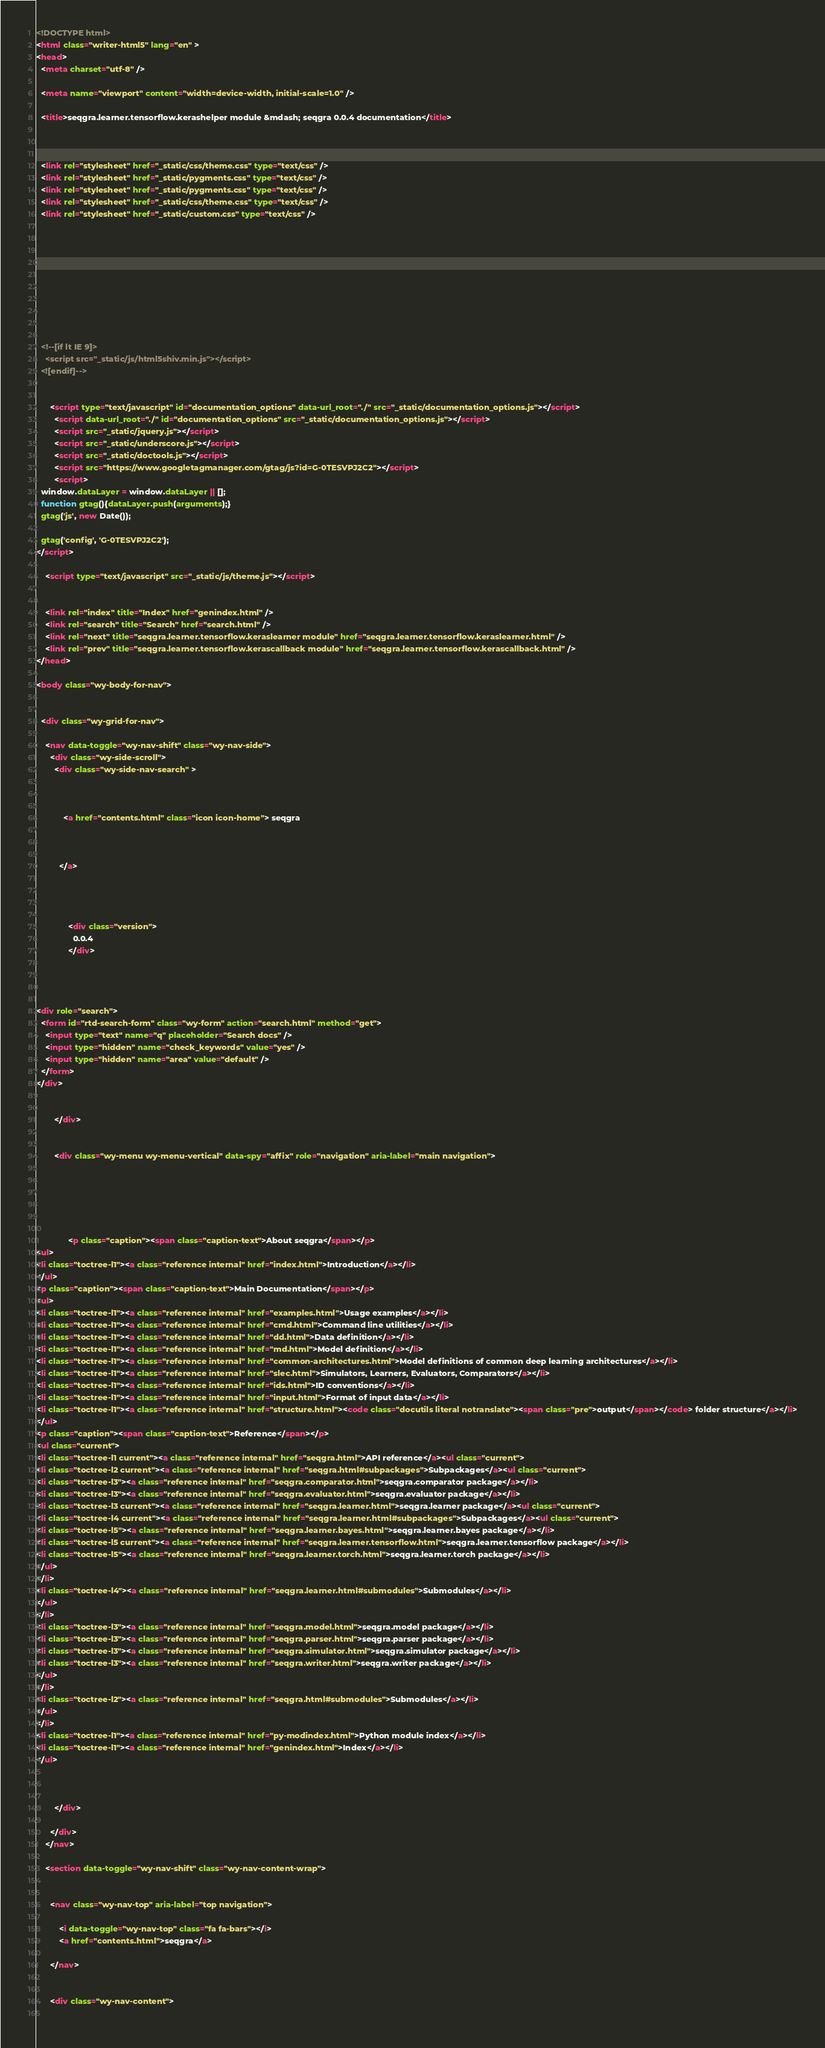Convert code to text. <code><loc_0><loc_0><loc_500><loc_500><_HTML_>

<!DOCTYPE html>
<html class="writer-html5" lang="en" >
<head>
  <meta charset="utf-8" />
  
  <meta name="viewport" content="width=device-width, initial-scale=1.0" />
  
  <title>seqgra.learner.tensorflow.kerashelper module &mdash; seqgra 0.0.4 documentation</title>
  

  
  <link rel="stylesheet" href="_static/css/theme.css" type="text/css" />
  <link rel="stylesheet" href="_static/pygments.css" type="text/css" />
  <link rel="stylesheet" href="_static/pygments.css" type="text/css" />
  <link rel="stylesheet" href="_static/css/theme.css" type="text/css" />
  <link rel="stylesheet" href="_static/custom.css" type="text/css" />

  
  

  
  

  

  
  <!--[if lt IE 9]>
    <script src="_static/js/html5shiv.min.js"></script>
  <![endif]-->
  
    
      <script type="text/javascript" id="documentation_options" data-url_root="./" src="_static/documentation_options.js"></script>
        <script data-url_root="./" id="documentation_options" src="_static/documentation_options.js"></script>
        <script src="_static/jquery.js"></script>
        <script src="_static/underscore.js"></script>
        <script src="_static/doctools.js"></script>
        <script src="https://www.googletagmanager.com/gtag/js?id=G-0TESVPJ2C2"></script>
        <script>
  window.dataLayer = window.dataLayer || [];
  function gtag(){dataLayer.push(arguments);}
  gtag('js', new Date());

  gtag('config', 'G-0TESVPJ2C2');
</script>
    
    <script type="text/javascript" src="_static/js/theme.js"></script>

    
    <link rel="index" title="Index" href="genindex.html" />
    <link rel="search" title="Search" href="search.html" />
    <link rel="next" title="seqgra.learner.tensorflow.keraslearner module" href="seqgra.learner.tensorflow.keraslearner.html" />
    <link rel="prev" title="seqgra.learner.tensorflow.kerascallback module" href="seqgra.learner.tensorflow.kerascallback.html" /> 
</head>

<body class="wy-body-for-nav">

   
  <div class="wy-grid-for-nav">
    
    <nav data-toggle="wy-nav-shift" class="wy-nav-side">
      <div class="wy-side-scroll">
        <div class="wy-side-nav-search" >
          

          
            <a href="contents.html" class="icon icon-home"> seqgra
          

          
          </a>

          
            
            
              <div class="version">
                0.0.4
              </div>
            
          

          
<div role="search">
  <form id="rtd-search-form" class="wy-form" action="search.html" method="get">
    <input type="text" name="q" placeholder="Search docs" />
    <input type="hidden" name="check_keywords" value="yes" />
    <input type="hidden" name="area" value="default" />
  </form>
</div>

          
        </div>

        
        <div class="wy-menu wy-menu-vertical" data-spy="affix" role="navigation" aria-label="main navigation">
          
            
            
              
            
            
              <p class="caption"><span class="caption-text">About seqgra</span></p>
<ul>
<li class="toctree-l1"><a class="reference internal" href="index.html">Introduction</a></li>
</ul>
<p class="caption"><span class="caption-text">Main Documentation</span></p>
<ul>
<li class="toctree-l1"><a class="reference internal" href="examples.html">Usage examples</a></li>
<li class="toctree-l1"><a class="reference internal" href="cmd.html">Command line utilities</a></li>
<li class="toctree-l1"><a class="reference internal" href="dd.html">Data definition</a></li>
<li class="toctree-l1"><a class="reference internal" href="md.html">Model definition</a></li>
<li class="toctree-l1"><a class="reference internal" href="common-architectures.html">Model definitions of common deep learning architectures</a></li>
<li class="toctree-l1"><a class="reference internal" href="slec.html">Simulators, Learners, Evaluators, Comparators</a></li>
<li class="toctree-l1"><a class="reference internal" href="ids.html">ID conventions</a></li>
<li class="toctree-l1"><a class="reference internal" href="input.html">Format of input data</a></li>
<li class="toctree-l1"><a class="reference internal" href="structure.html"><code class="docutils literal notranslate"><span class="pre">output</span></code> folder structure</a></li>
</ul>
<p class="caption"><span class="caption-text">Reference</span></p>
<ul class="current">
<li class="toctree-l1 current"><a class="reference internal" href="seqgra.html">API reference</a><ul class="current">
<li class="toctree-l2 current"><a class="reference internal" href="seqgra.html#subpackages">Subpackages</a><ul class="current">
<li class="toctree-l3"><a class="reference internal" href="seqgra.comparator.html">seqgra.comparator package</a></li>
<li class="toctree-l3"><a class="reference internal" href="seqgra.evaluator.html">seqgra.evaluator package</a></li>
<li class="toctree-l3 current"><a class="reference internal" href="seqgra.learner.html">seqgra.learner package</a><ul class="current">
<li class="toctree-l4 current"><a class="reference internal" href="seqgra.learner.html#subpackages">Subpackages</a><ul class="current">
<li class="toctree-l5"><a class="reference internal" href="seqgra.learner.bayes.html">seqgra.learner.bayes package</a></li>
<li class="toctree-l5 current"><a class="reference internal" href="seqgra.learner.tensorflow.html">seqgra.learner.tensorflow package</a></li>
<li class="toctree-l5"><a class="reference internal" href="seqgra.learner.torch.html">seqgra.learner.torch package</a></li>
</ul>
</li>
<li class="toctree-l4"><a class="reference internal" href="seqgra.learner.html#submodules">Submodules</a></li>
</ul>
</li>
<li class="toctree-l3"><a class="reference internal" href="seqgra.model.html">seqgra.model package</a></li>
<li class="toctree-l3"><a class="reference internal" href="seqgra.parser.html">seqgra.parser package</a></li>
<li class="toctree-l3"><a class="reference internal" href="seqgra.simulator.html">seqgra.simulator package</a></li>
<li class="toctree-l3"><a class="reference internal" href="seqgra.writer.html">seqgra.writer package</a></li>
</ul>
</li>
<li class="toctree-l2"><a class="reference internal" href="seqgra.html#submodules">Submodules</a></li>
</ul>
</li>
<li class="toctree-l1"><a class="reference internal" href="py-modindex.html">Python module index</a></li>
<li class="toctree-l1"><a class="reference internal" href="genindex.html">Index</a></li>
</ul>

            
          
        </div>
        
      </div>
    </nav>

    <section data-toggle="wy-nav-shift" class="wy-nav-content-wrap">

      
      <nav class="wy-nav-top" aria-label="top navigation">
        
          <i data-toggle="wy-nav-top" class="fa fa-bars"></i>
          <a href="contents.html">seqgra</a>
        
      </nav>


      <div class="wy-nav-content">
        </code> 